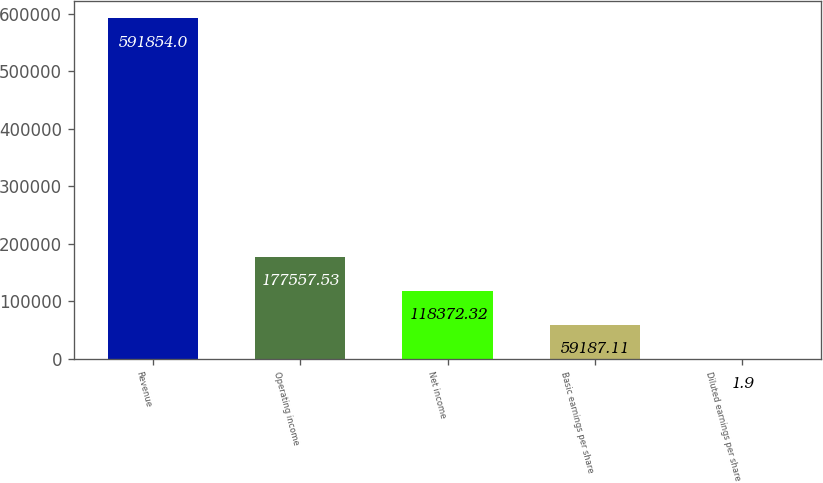<chart> <loc_0><loc_0><loc_500><loc_500><bar_chart><fcel>Revenue<fcel>Operating income<fcel>Net income<fcel>Basic earnings per share<fcel>Diluted earnings per share<nl><fcel>591854<fcel>177558<fcel>118372<fcel>59187.1<fcel>1.9<nl></chart> 